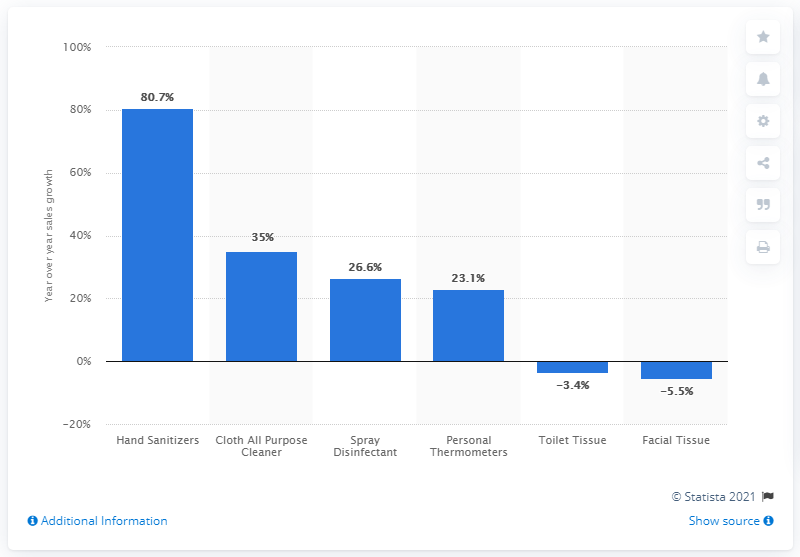Highlight a few significant elements in this photo. The sales of hand sanitizers at drug stores increased by 80.7% in the week ended February 23, 2020. The sales of personal thermometers in drug stores increased by 23.1% in the week ended February 23, 2020. 